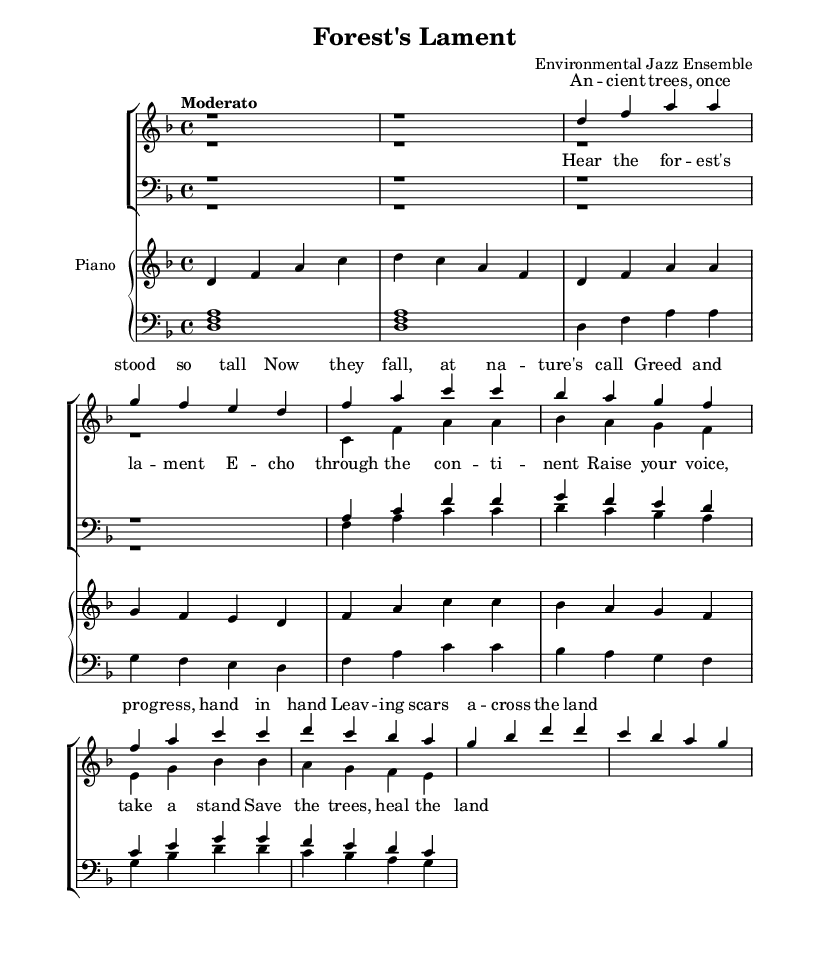What is the key signature of this music? The key signature displayed in the music indicates D minor, which is represented by one flat (B flat).
Answer: D minor What is the time signature of this music? The time signature shown is 4/4, which means there are four beats in a measure and the quarter note gets one beat.
Answer: 4/4 What is the tempo marking for this piece? The tempo marking in the music states "Moderato," which suggests a moderate pace for the piece.
Answer: Moderato How many measures are in the soprano part? Counting the measures in the soprano part, there are a total of eight measures presented in the music.
Answer: Eight What is the highest pitch note in the soprano vocal line? In the soprano line, the highest pitch note is A, which appears in the second measure of the vocal line.
Answer: A How many choral parts are there in total? The score includes four distinct parts: soprano, alto, tenor, and bass, making a total of four choral parts.
Answer: Four What lyrical theme is prevalent in the chorus? The lyrics of the chorus emphasize environmental advocacy and the preservation of nature, highlighting the theme of saving forests and healing the land.
Answer: Environmental advocacy 